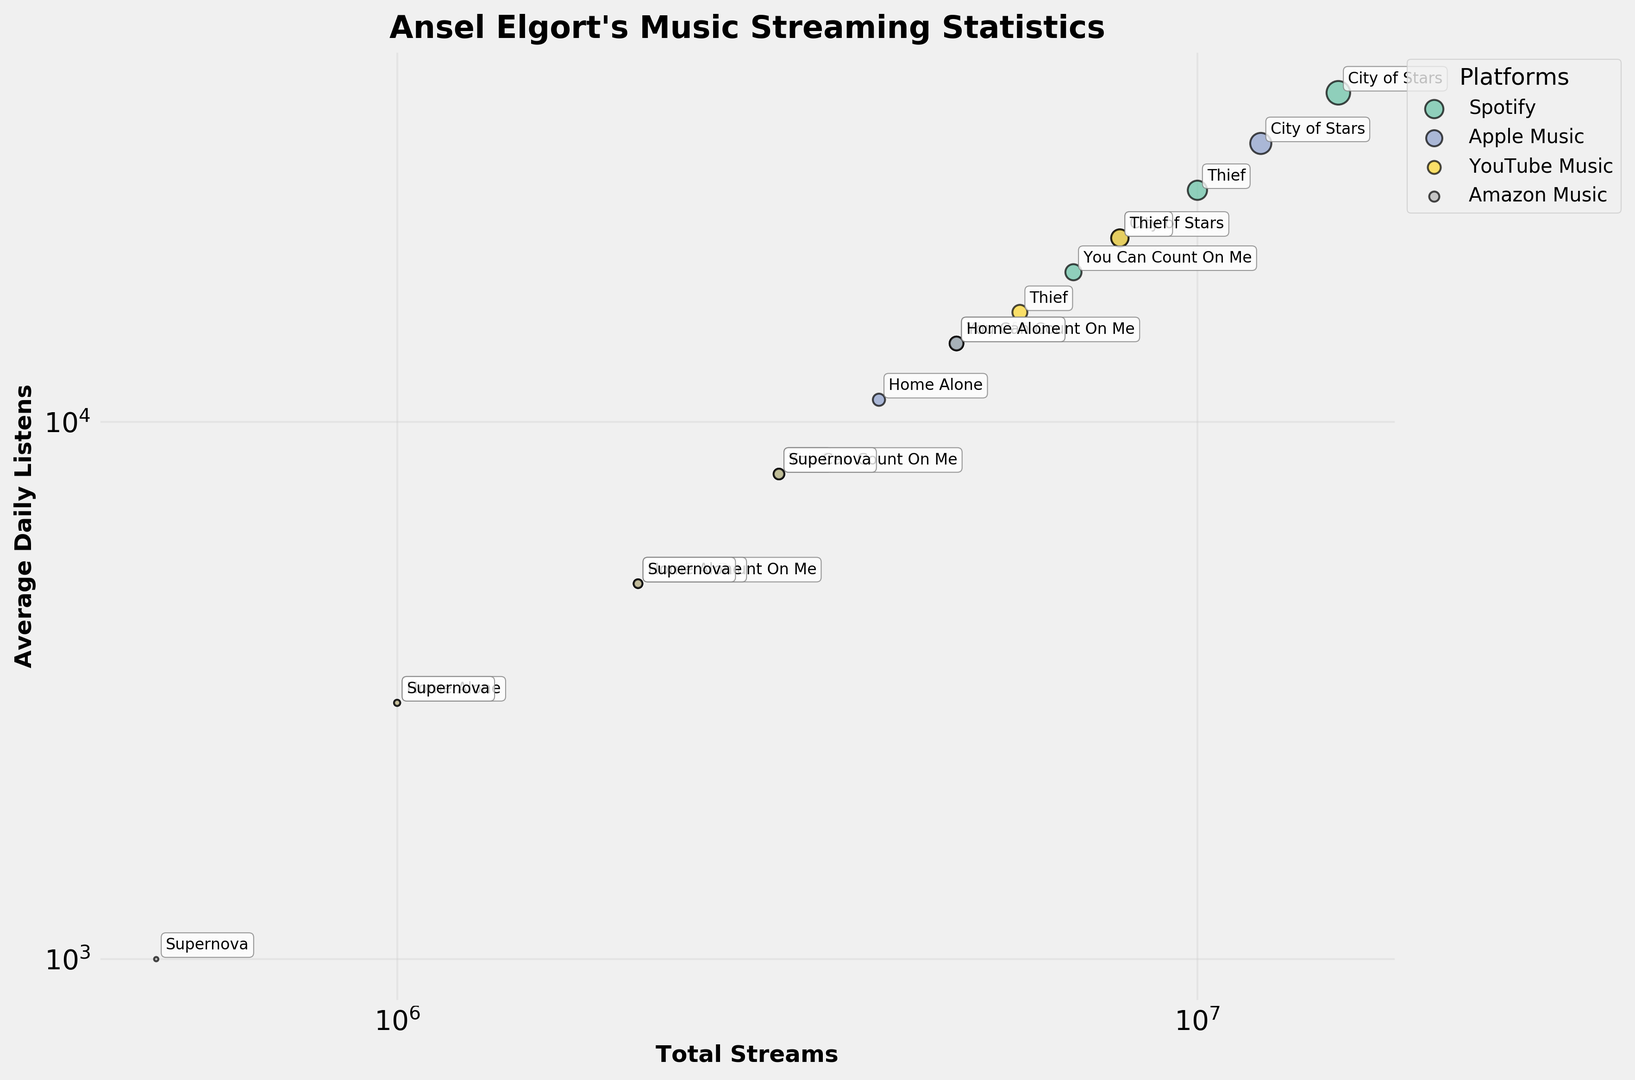What song has the highest average daily listens on Spotify? By examining the bubble chart, identify the largest bubble specifically colored to represent Spotify. The label next to this bubble will indicate which song it is.
Answer: City of Stars What is the total number of streams for "Thief" across all platforms? Locate the bubbles labeled "Thief" on the chart and note their sizes. Sum the values of these streams: 10,000,000 (Spotify) + 8,000,000 (Apple Music) + 6,000,000 (YouTube Music) + 3,000,000 (Amazon Music).
Answer: 27,000,000 Which platform has the lowest average daily listens for "Supernova"? Identify the bubbles labeled "Supernova" and note their positions on the y-axis. The one positioned lowest represents the platform with the fewest average daily listens.
Answer: Amazon Music On which platform does "You Can Count On Me" have more average daily listens than "Home Alone"? Compare the y-axis values (average daily listens) of "You Can Count On Me" and "Home Alone" within each platform. Identify the platform(s) with a higher value for "You Can Count On Me".
Answer: Spotify Which platform contributes the most to the streams of "City of Stars"? Find the bubbles labeled "City of Stars" and compare their sizes (representing the number of streams). The platform associated with the largest bubble has the most streams.
Answer: Spotify Which song has the smallest number of streams on Amazon Music? Look for the smallest bubble within the Amazon Music category. The label next to it will indicate the song.
Answer: Supernova What is the total average daily listen count for all songs on YouTube Music? Find all the bubbles representing YouTube Music, and sum their values for "Average Daily Listens": 22,000 ("City of Stars") + 16,000 ("Thief") + 8,000 ("You Can Count On Me") + 5,000 ("Home Alone") + 3,000 ("Supernova").
Answer: 54,000 Which song has a larger number of streams on Apple Music: "City of Stars" or "Thief"? Compare the sizes of the bubbles labeled "City of Stars" and "Thief" within the Apple Music category. The larger bubble represents the song with more streams.
Answer: City of Stars What is the average daily listens difference between "Home Alone" on Spotify and Apple Music? Identify the bubbles labeled "Home Alone" for Spotify and Apple Music. Note their y-axis values and find the difference: 14,000 (Spotify) - 11,000 (Apple Music).
Answer: 3,000 Are there any songs with the same average daily listens across different platforms? Look for any horizontally aligned bubbles with the same y-axis value within the same label (song).
Answer: No 